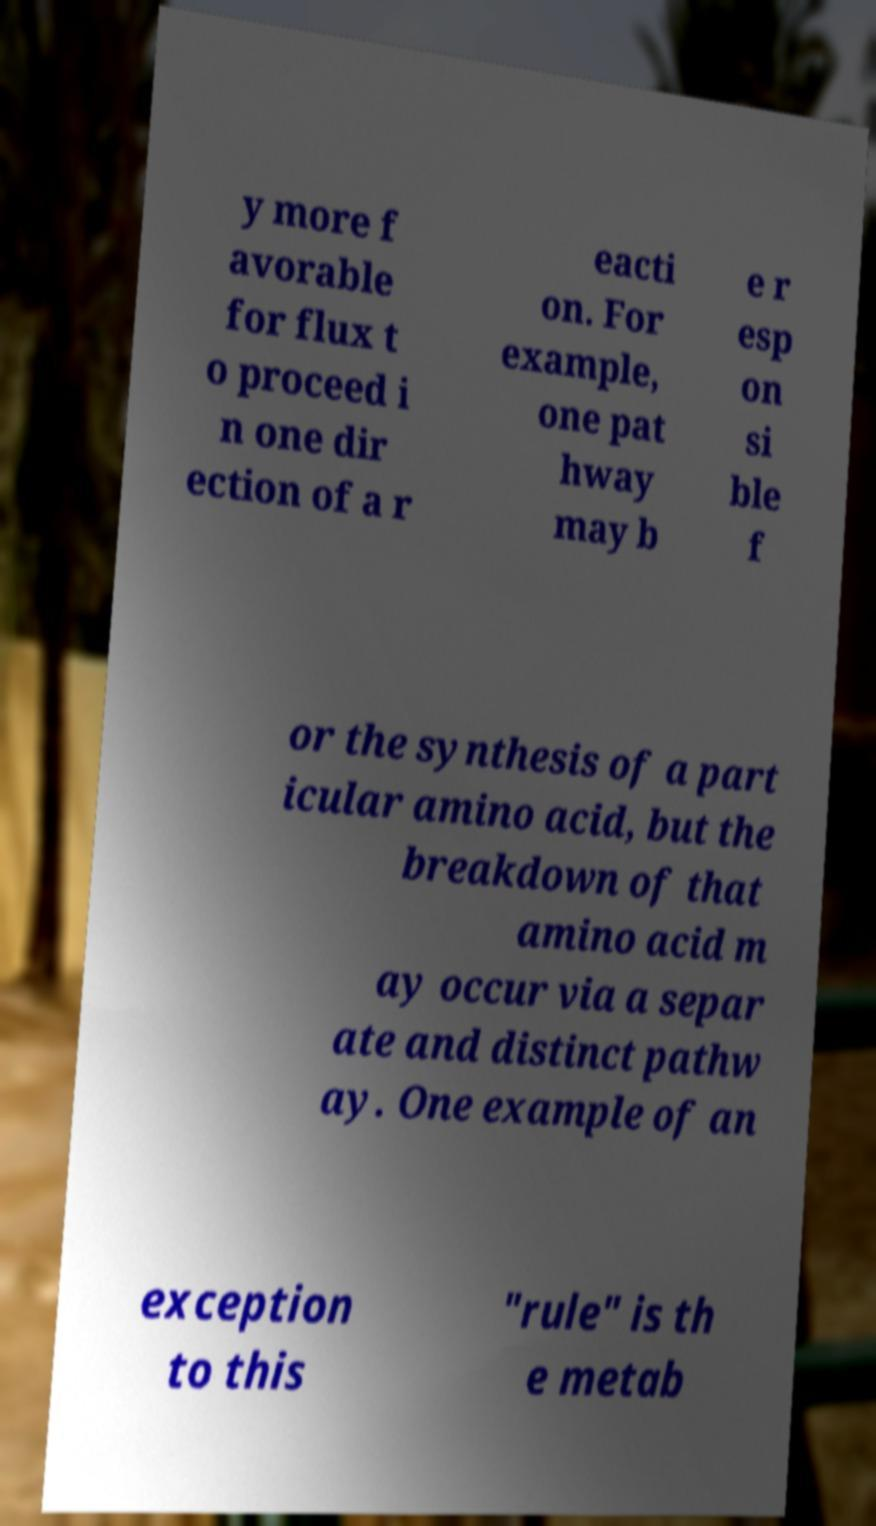There's text embedded in this image that I need extracted. Can you transcribe it verbatim? y more f avorable for flux t o proceed i n one dir ection of a r eacti on. For example, one pat hway may b e r esp on si ble f or the synthesis of a part icular amino acid, but the breakdown of that amino acid m ay occur via a separ ate and distinct pathw ay. One example of an exception to this "rule" is th e metab 